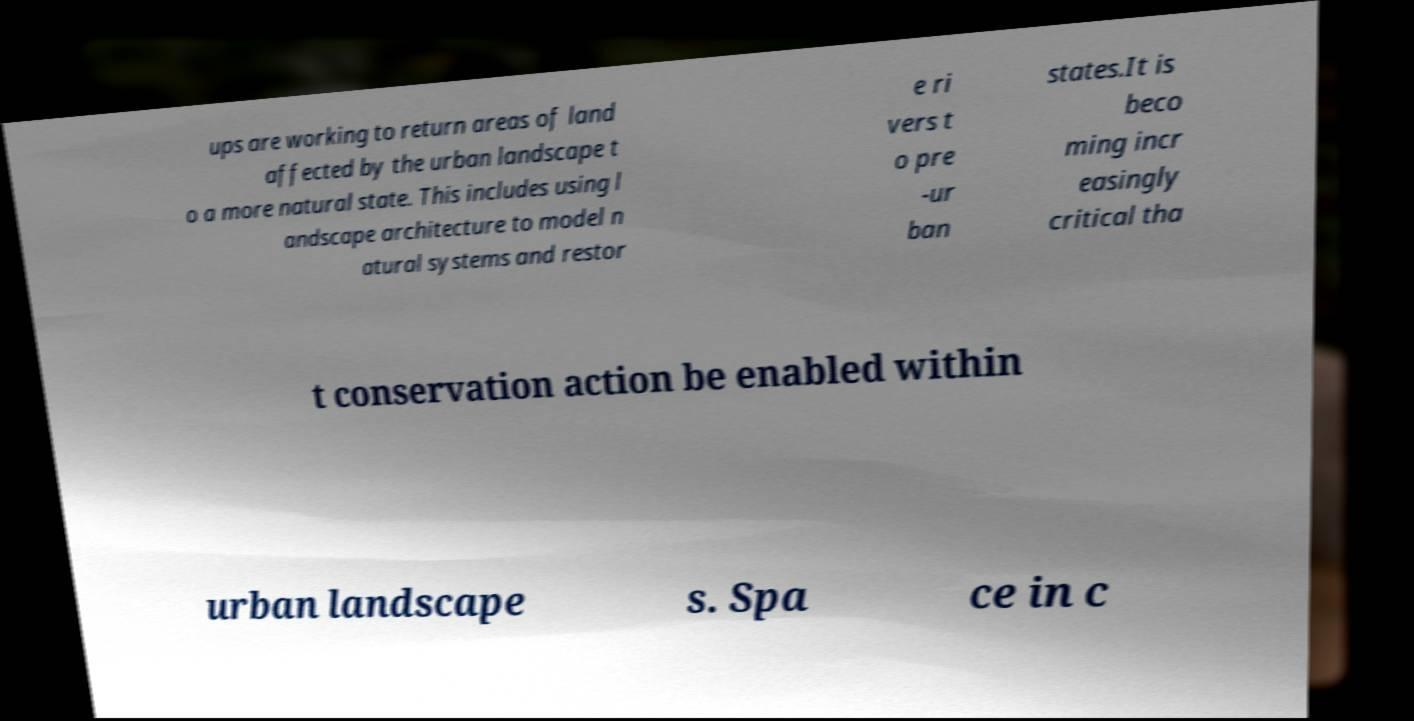Can you read and provide the text displayed in the image?This photo seems to have some interesting text. Can you extract and type it out for me? ups are working to return areas of land affected by the urban landscape t o a more natural state. This includes using l andscape architecture to model n atural systems and restor e ri vers t o pre -ur ban states.It is beco ming incr easingly critical tha t conservation action be enabled within urban landscape s. Spa ce in c 